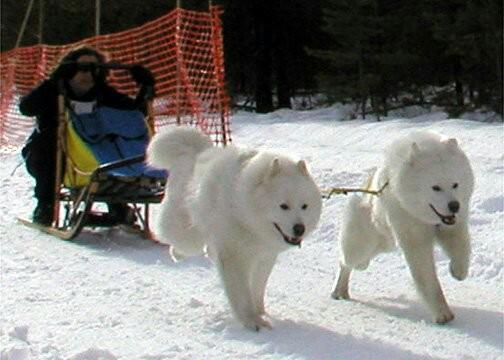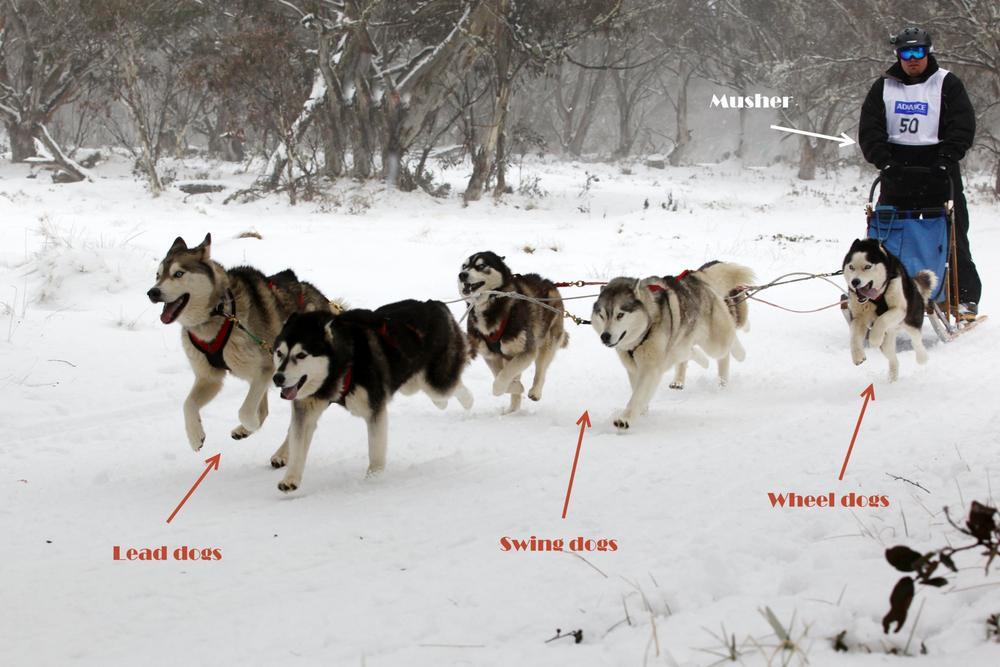The first image is the image on the left, the second image is the image on the right. Examine the images to the left and right. Is the description "Two light colored dogs are pulling a sled in one of the images." accurate? Answer yes or no. Yes. The first image is the image on the left, the second image is the image on the right. For the images displayed, is the sentence "There are at least two people sitting down riding a sled." factually correct? Answer yes or no. No. 